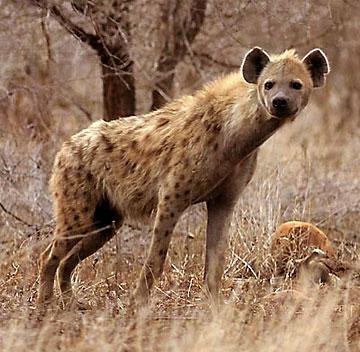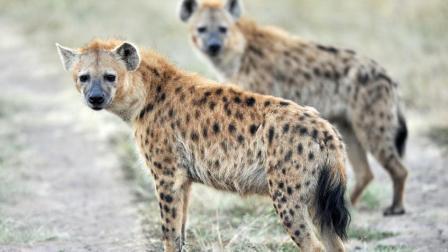The first image is the image on the left, the second image is the image on the right. Examine the images to the left and right. Is the description "Exactly one hyena is baring its fangs with wide-opened mouth, and no image shows hyenas posed face-to-face." accurate? Answer yes or no. No. The first image is the image on the left, the second image is the image on the right. For the images displayed, is the sentence "Exactly one hyena's teeth are visible." factually correct? Answer yes or no. No. 